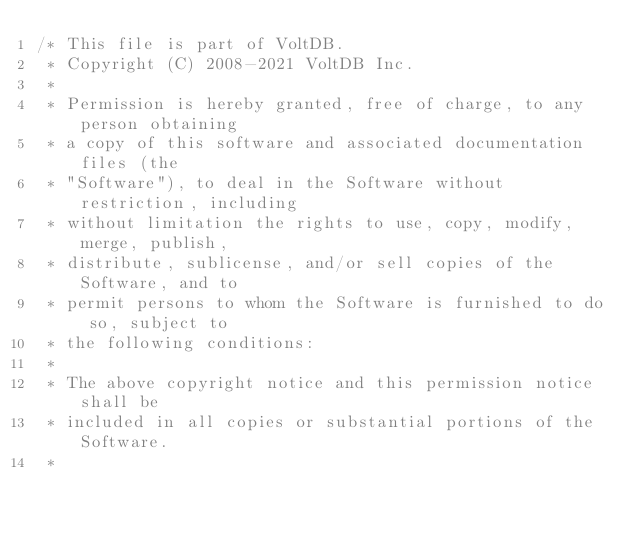<code> <loc_0><loc_0><loc_500><loc_500><_Java_>/* This file is part of VoltDB.
 * Copyright (C) 2008-2021 VoltDB Inc.
 *
 * Permission is hereby granted, free of charge, to any person obtaining
 * a copy of this software and associated documentation files (the
 * "Software"), to deal in the Software without restriction, including
 * without limitation the rights to use, copy, modify, merge, publish,
 * distribute, sublicense, and/or sell copies of the Software, and to
 * permit persons to whom the Software is furnished to do so, subject to
 * the following conditions:
 *
 * The above copyright notice and this permission notice shall be
 * included in all copies or substantial portions of the Software.
 *</code> 